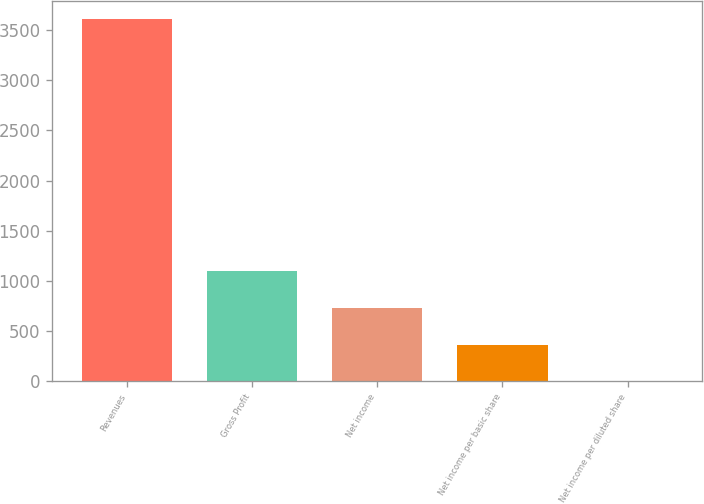Convert chart. <chart><loc_0><loc_0><loc_500><loc_500><bar_chart><fcel>Revenues<fcel>Gross Profit<fcel>Net income<fcel>Net income per basic share<fcel>Net income per diluted share<nl><fcel>3611.6<fcel>1100<fcel>723.37<fcel>362.34<fcel>1.31<nl></chart> 